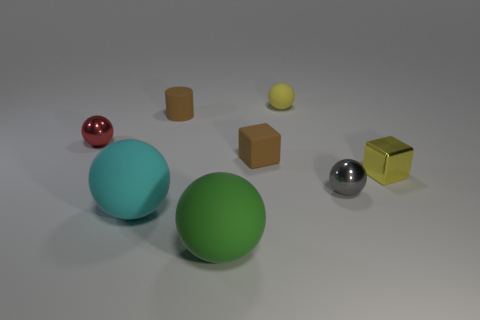How many small gray balls are the same material as the small brown cylinder?
Provide a succinct answer. 0. There is a tiny yellow thing left of the tiny metal block; how many yellow metal blocks are left of it?
Give a very brief answer. 0. Are there any green balls on the left side of the brown block?
Provide a short and direct response. Yes. Is the shape of the cyan object to the left of the small brown rubber cylinder the same as  the yellow rubber object?
Keep it short and to the point. Yes. What material is the tiny thing that is the same color as the tiny rubber sphere?
Offer a terse response. Metal. What number of small shiny objects have the same color as the tiny rubber sphere?
Your response must be concise. 1. What shape is the thing that is to the right of the small shiny sphere right of the tiny red object?
Keep it short and to the point. Cube. Are there any brown rubber objects that have the same shape as the large green object?
Make the answer very short. No. There is a rubber cylinder; is it the same color as the small matte thing in front of the small brown matte cylinder?
Your answer should be very brief. Yes. What is the size of the rubber object that is the same color as the tiny metal block?
Your answer should be compact. Small. 